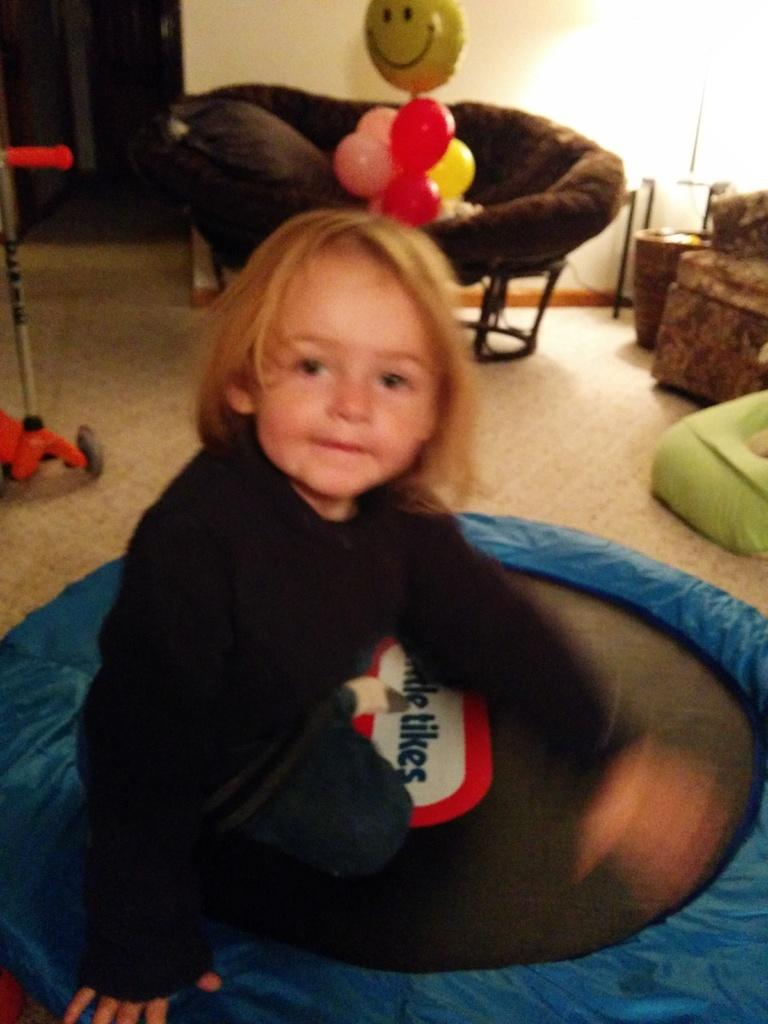What is the child doing in the image? The child is sitting on an object in the image. What can be seen in the background of the image? There are balloons, a wall, a chair, and a door in the background of the image. Can you describe the object the child is sitting on? The object the child is sitting on is not specified in the facts provided. What type of animals can be seen at the zoo in the image? There is no zoo present in the image, so it is not possible to determine what, if any, animals might be seen. 